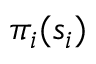<formula> <loc_0><loc_0><loc_500><loc_500>\pi _ { i } ( s _ { i } )</formula> 